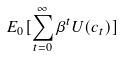<formula> <loc_0><loc_0><loc_500><loc_500>E _ { 0 } [ \sum _ { t = 0 } ^ { \infty } \beta ^ { t } U ( c _ { t } ) ]</formula> 